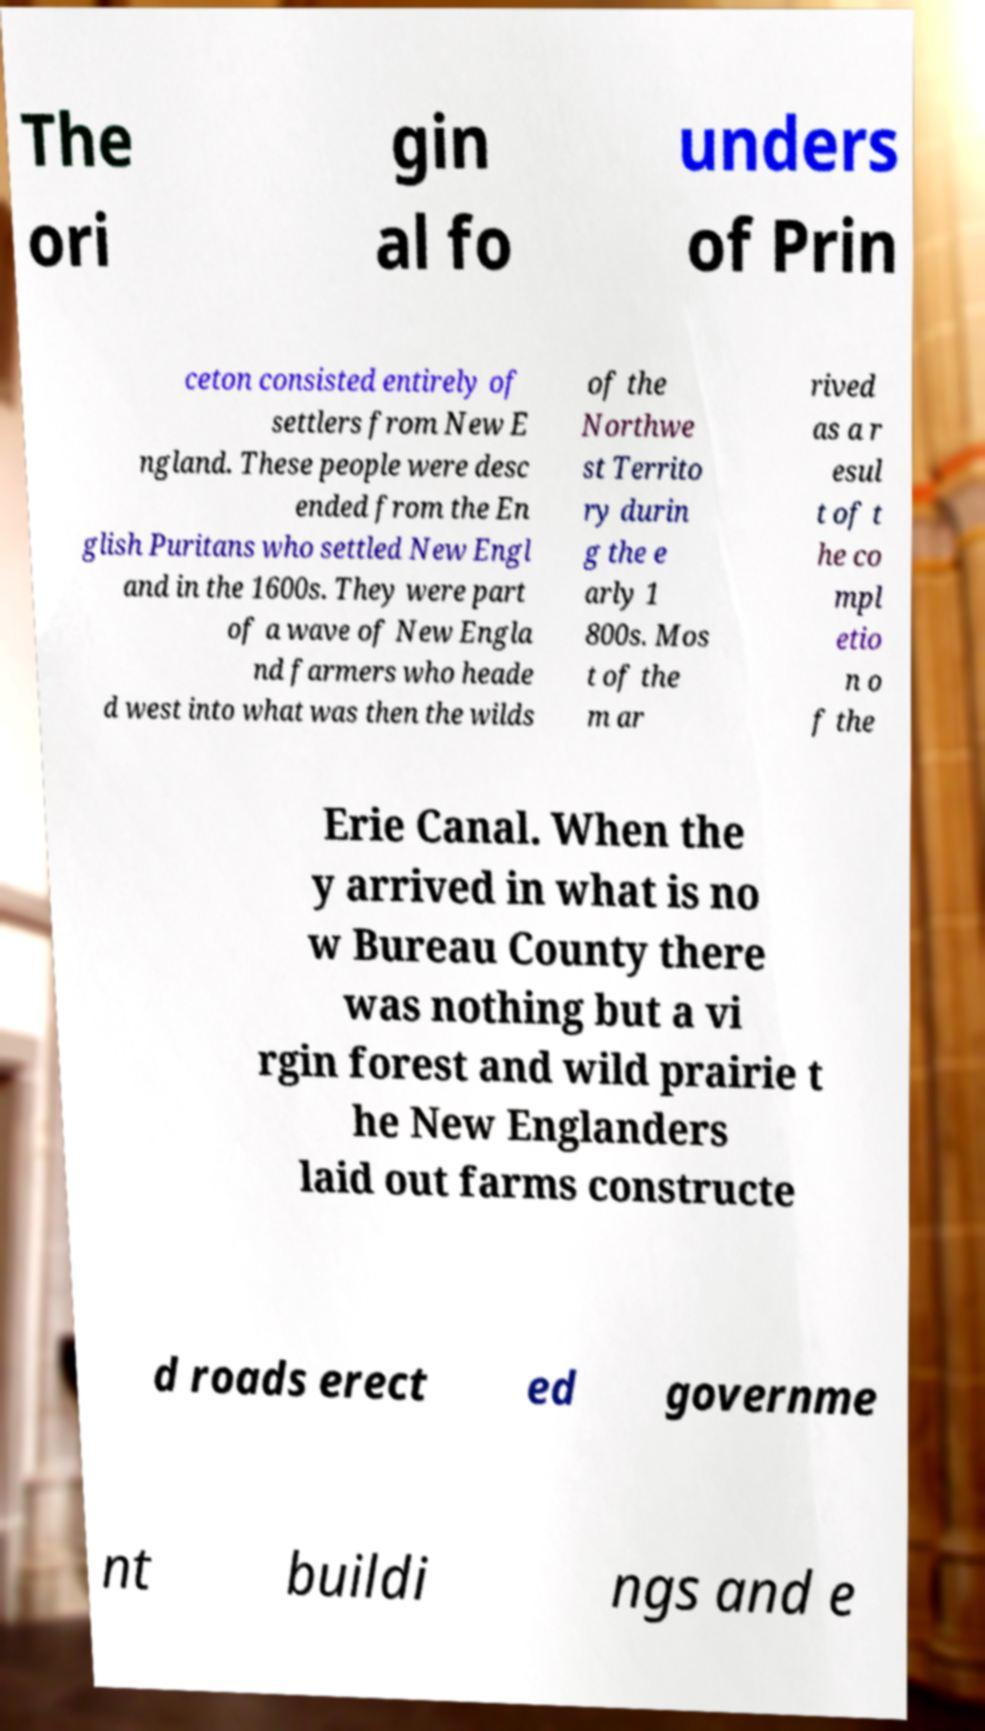There's text embedded in this image that I need extracted. Can you transcribe it verbatim? The ori gin al fo unders of Prin ceton consisted entirely of settlers from New E ngland. These people were desc ended from the En glish Puritans who settled New Engl and in the 1600s. They were part of a wave of New Engla nd farmers who heade d west into what was then the wilds of the Northwe st Territo ry durin g the e arly 1 800s. Mos t of the m ar rived as a r esul t of t he co mpl etio n o f the Erie Canal. When the y arrived in what is no w Bureau County there was nothing but a vi rgin forest and wild prairie t he New Englanders laid out farms constructe d roads erect ed governme nt buildi ngs and e 